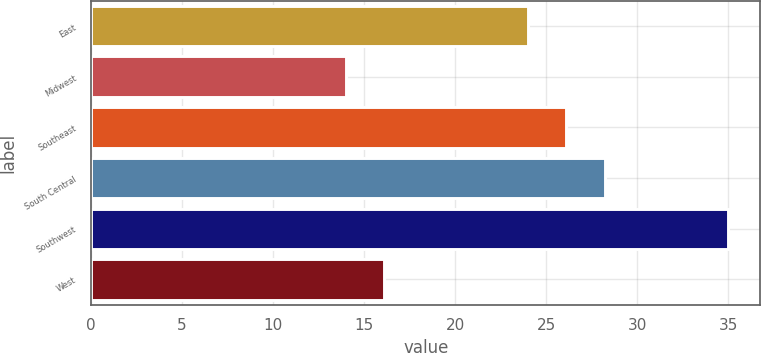Convert chart to OTSL. <chart><loc_0><loc_0><loc_500><loc_500><bar_chart><fcel>East<fcel>Midwest<fcel>Southeast<fcel>South Central<fcel>Southwest<fcel>West<nl><fcel>24<fcel>14<fcel>26.1<fcel>28.2<fcel>35<fcel>16.1<nl></chart> 